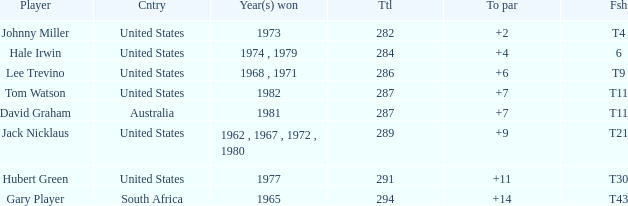WHAT IS THE TOTAL THAT HAS A WIN IN 1982? 287.0. 